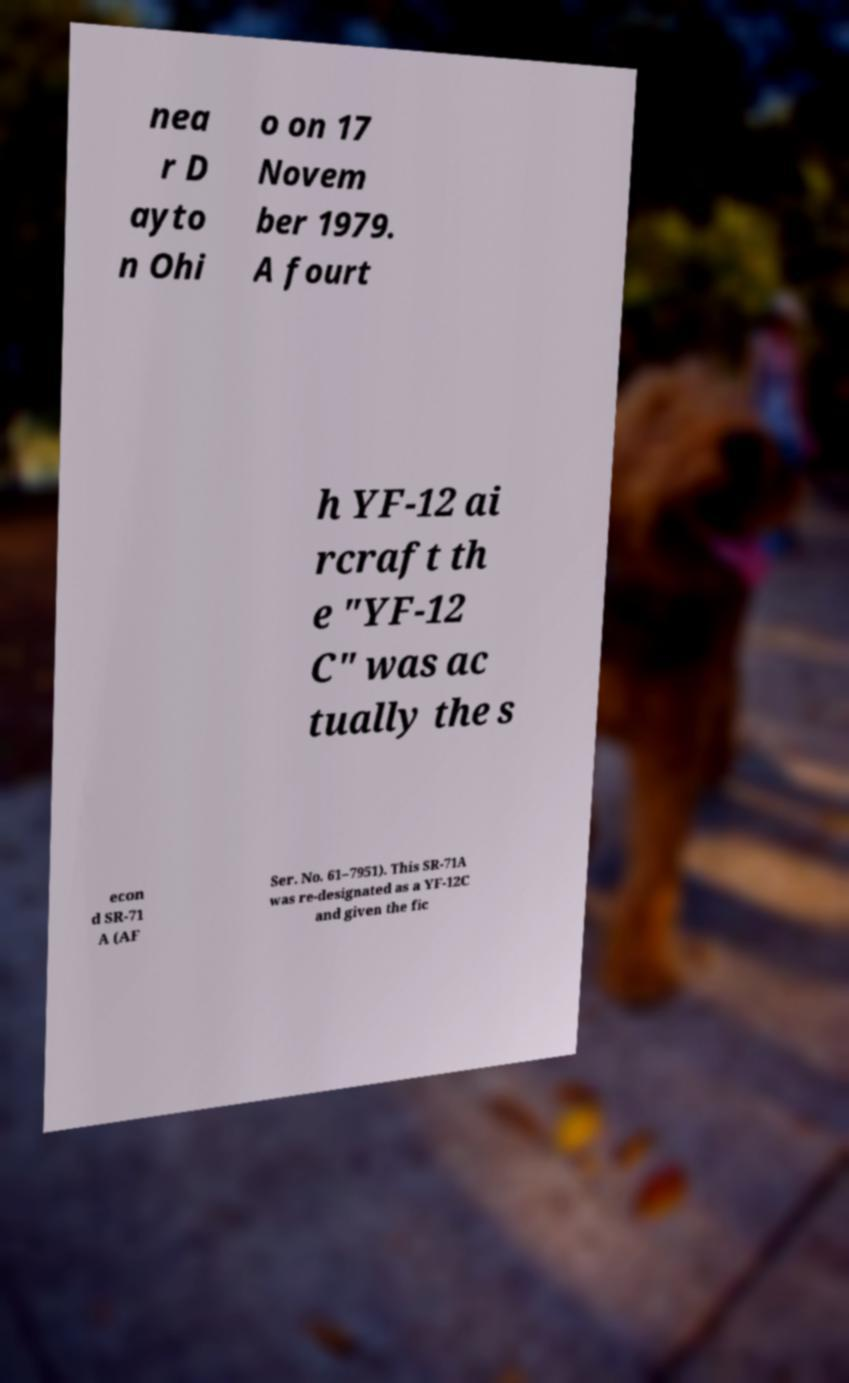Can you accurately transcribe the text from the provided image for me? nea r D ayto n Ohi o on 17 Novem ber 1979. A fourt h YF-12 ai rcraft th e "YF-12 C" was ac tually the s econ d SR-71 A (AF Ser. No. 61–7951). This SR-71A was re-designated as a YF-12C and given the fic 